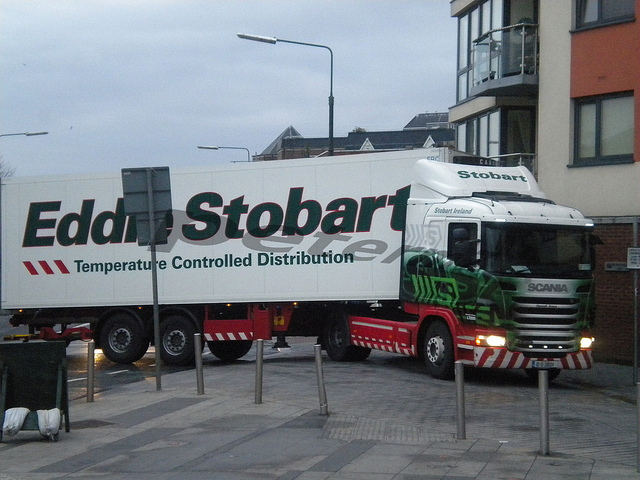<image>What city was the photo taken in? I don't know which city the photo was taken in. It could be Leeds, Austin, San Francisco, New York, Chicago, Belfast, or Petersburg. What city was the photo taken in? It is ambiguous what city the photo was taken in. It can be either 'leeds', 'austin', 'san francisco', 'unknown', 'new york', 'new york', 'new york', 'chicago', 'belfast', or 'petersburg'. 